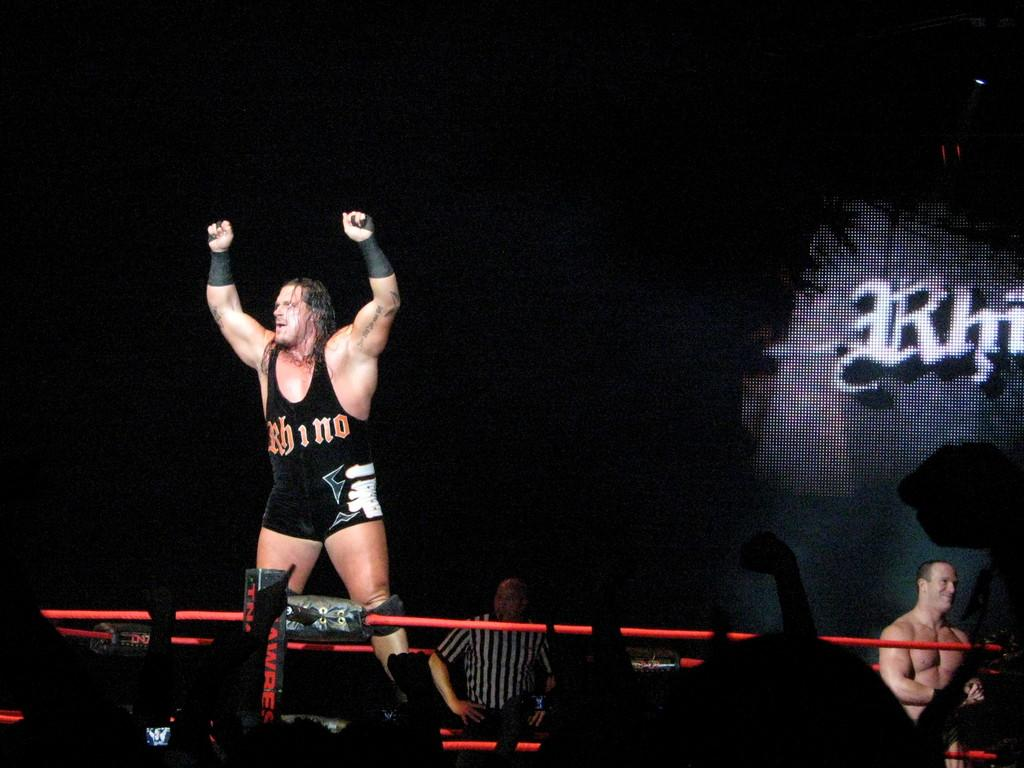<image>
Write a terse but informative summary of the picture. A wrestler whose shirt says Rhino with his hands over his head. 